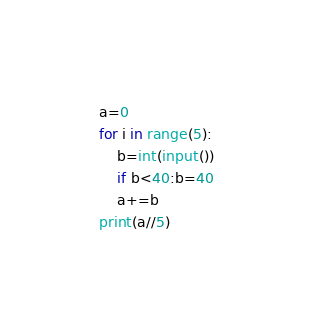Convert code to text. <code><loc_0><loc_0><loc_500><loc_500><_Python_>a=0
for i in range(5):
    b=int(input())
    if b<40:b=40
    a+=b
print(a//5)
</code> 